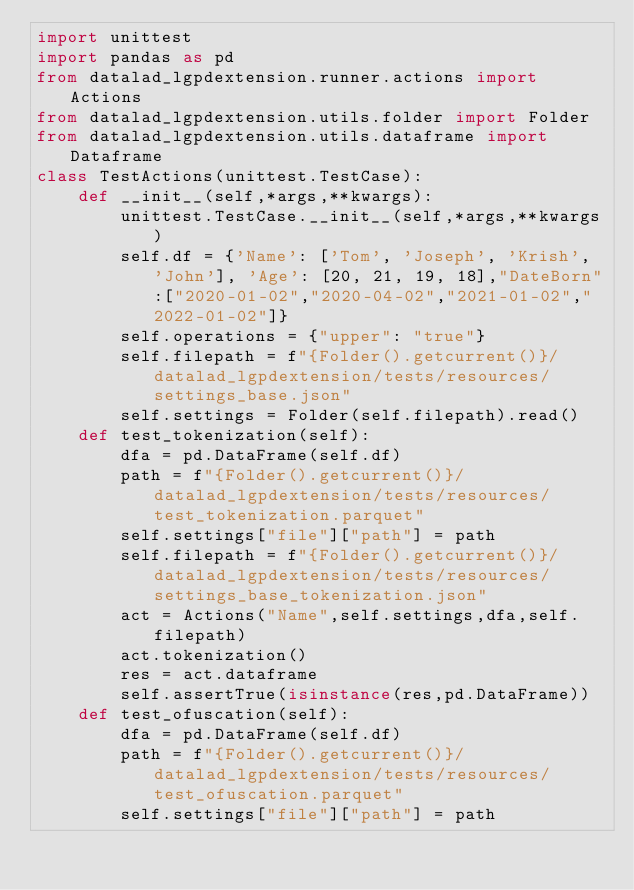Convert code to text. <code><loc_0><loc_0><loc_500><loc_500><_Python_>import unittest
import pandas as pd
from datalad_lgpdextension.runner.actions import Actions
from datalad_lgpdextension.utils.folder import Folder
from datalad_lgpdextension.utils.dataframe import Dataframe
class TestActions(unittest.TestCase):
    def __init__(self,*args,**kwargs):
        unittest.TestCase.__init__(self,*args,**kwargs)
        self.df = {'Name': ['Tom', 'Joseph', 'Krish', 'John'], 'Age': [20, 21, 19, 18],"DateBorn":["2020-01-02","2020-04-02","2021-01-02","2022-01-02"]}  
        self.operations = {"upper": "true"}
        self.filepath = f"{Folder().getcurrent()}/datalad_lgpdextension/tests/resources/settings_base.json"
        self.settings = Folder(self.filepath).read()
    def test_tokenization(self):
        dfa = pd.DataFrame(self.df)
        path = f"{Folder().getcurrent()}/datalad_lgpdextension/tests/resources/test_tokenization.parquet"
        self.settings["file"]["path"] = path
        self.filepath = f"{Folder().getcurrent()}/datalad_lgpdextension/tests/resources/settings_base_tokenization.json"
        act = Actions("Name",self.settings,dfa,self.filepath)
        act.tokenization()
        res = act.dataframe
        self.assertTrue(isinstance(res,pd.DataFrame))
    def test_ofuscation(self):
        dfa = pd.DataFrame(self.df)
        path = f"{Folder().getcurrent()}/datalad_lgpdextension/tests/resources/test_ofuscation.parquet"
        self.settings["file"]["path"] = path</code> 